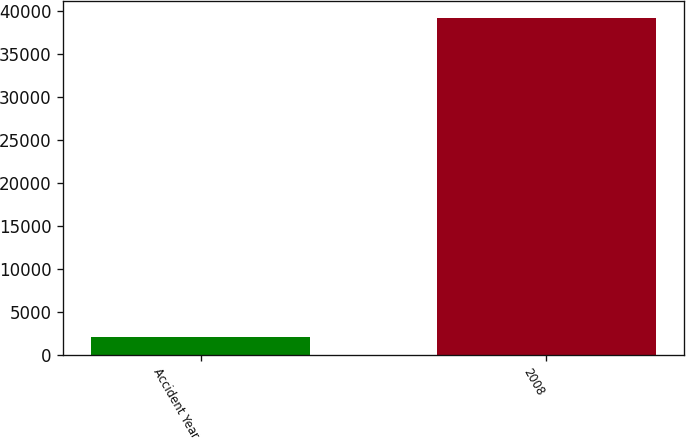Convert chart to OTSL. <chart><loc_0><loc_0><loc_500><loc_500><bar_chart><fcel>Accident Year<fcel>2008<nl><fcel>2014<fcel>39193<nl></chart> 